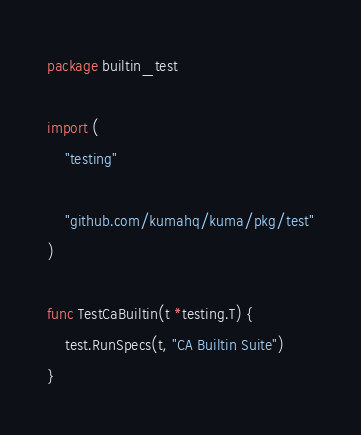<code> <loc_0><loc_0><loc_500><loc_500><_Go_>package builtin_test

import (
	"testing"

	"github.com/kumahq/kuma/pkg/test"
)

func TestCaBuiltin(t *testing.T) {
	test.RunSpecs(t, "CA Builtin Suite")
}
</code> 